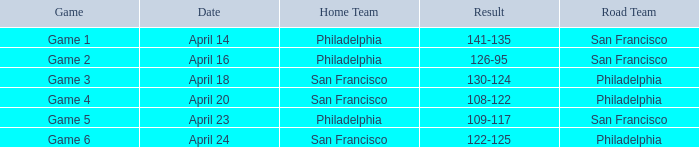Which game was played in philadelphia as the home team on april 23? Game 5. 